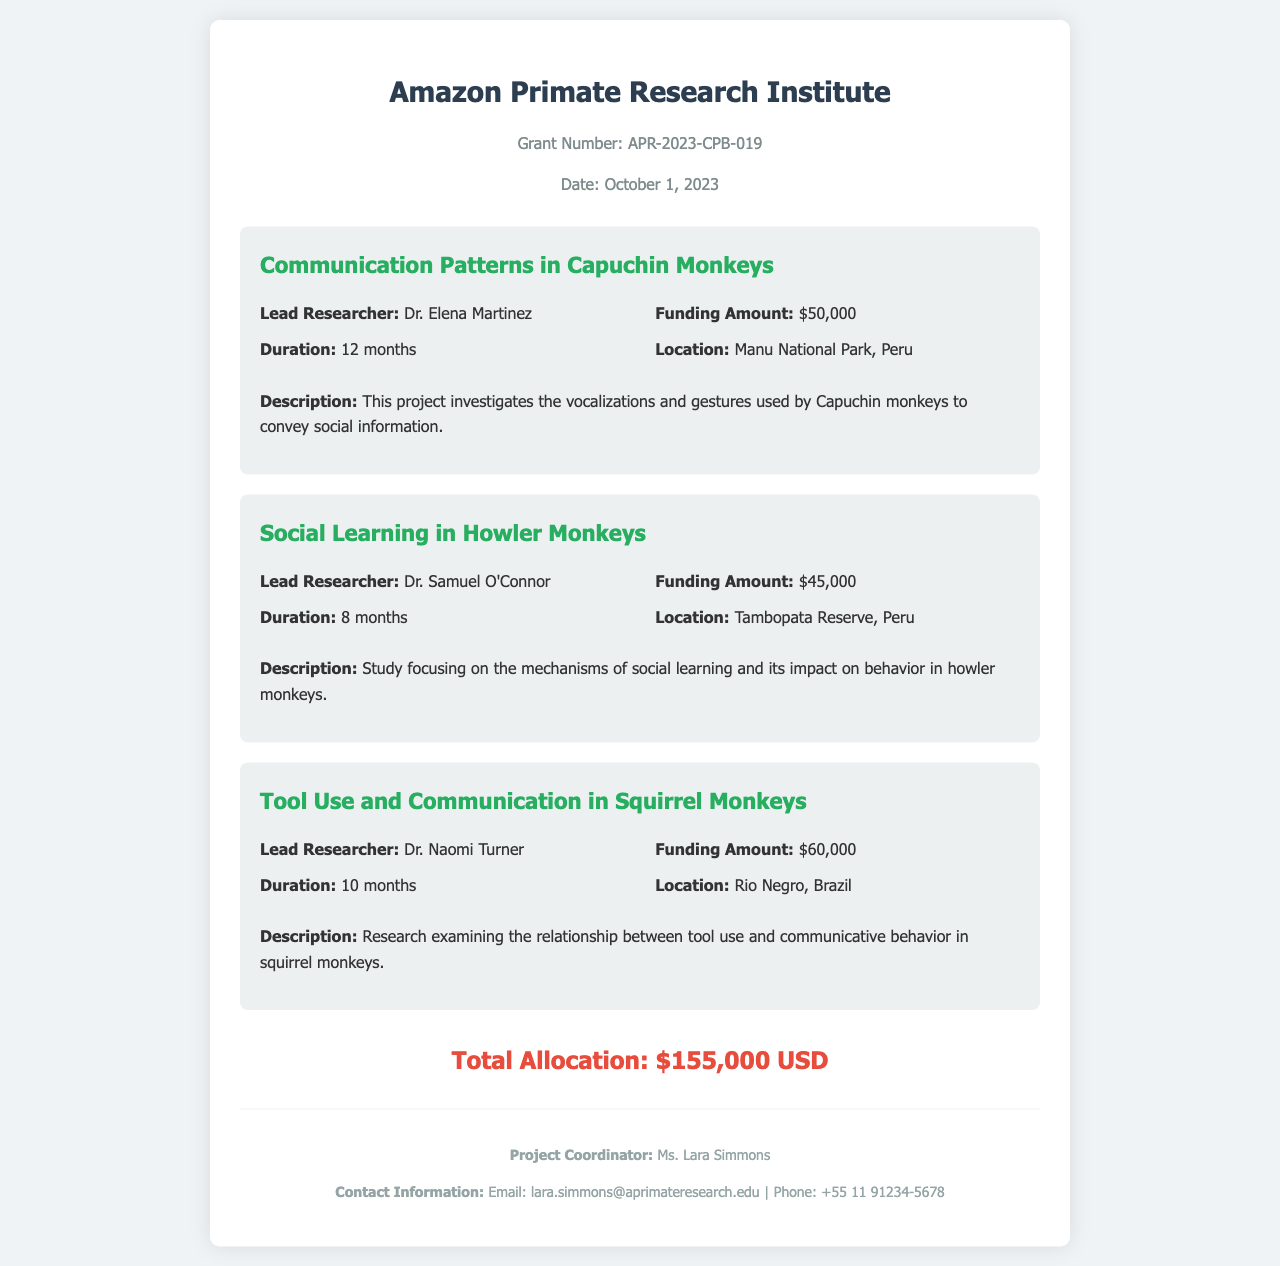What is the grant number? The grant number is specified at the top of the document, indicating the unique identifier for this funding allocation.
Answer: APR-2023-CPB-019 Who is the lead researcher for the project on Communication Patterns in Capuchin Monkeys? The document lists the lead researcher for this project in the respective project section.
Answer: Dr. Elena Martinez How much funding was allocated for Social Learning in Howler Monkeys? The funding amount is clearly stated in the details of the corresponding project.
Answer: $45,000 What is the duration of the Tool Use and Communication in Squirrel Monkeys project? The duration is indicated in the project details section for this specific research initiative.
Answer: 10 months What is the total allocation for all projects combined? The total allocation is summarized at the end of the document, reflecting the entire funding amount.
Answer: $155,000 USD Where is the Howler Monkeys project located? The location for this research project can be found in the details section of the corresponding project description.
Answer: Tambopata Reserve, Peru Who is the project coordinator? The document includes the name of the project coordinator in the footer section.
Answer: Ms. Lara Simmons What is the funding amount for the project on Tool Use and Communication in Squirrel Monkeys? The funding amount for this particular project is detailed in its project section.
Answer: $60,000 